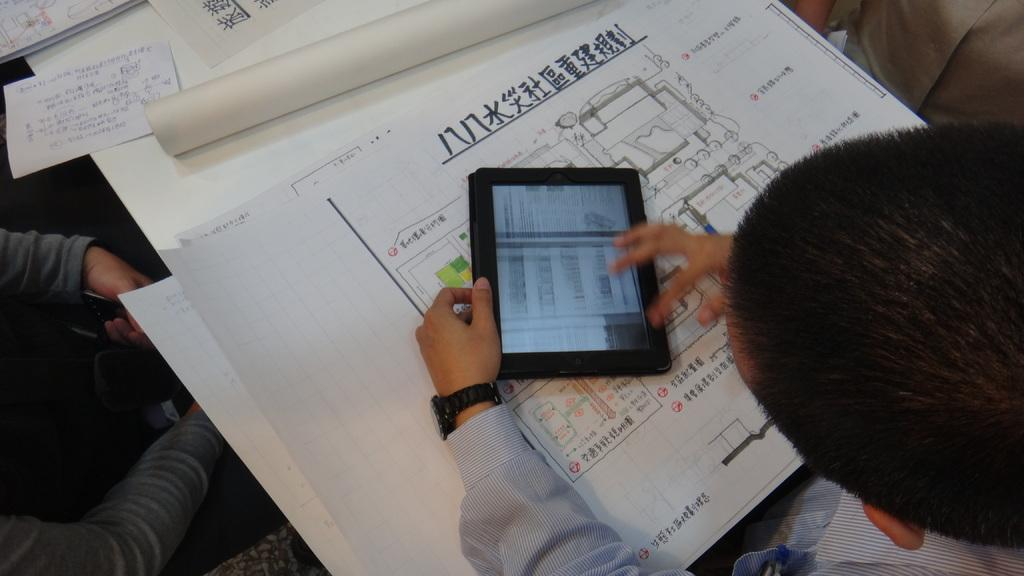What is the person in the image doing? The person in the image is using an iPad. What is present on the table in the image? There are charts on the table. Can you describe the setting in the image? There is a table and another person on the left side of the image. What type of metal is the tank made of in the image? There is no tank present in the image. How does the person's mind appear in the image? The image does not show the person's mind; it only shows the person using an iPad and the surrounding objects. 